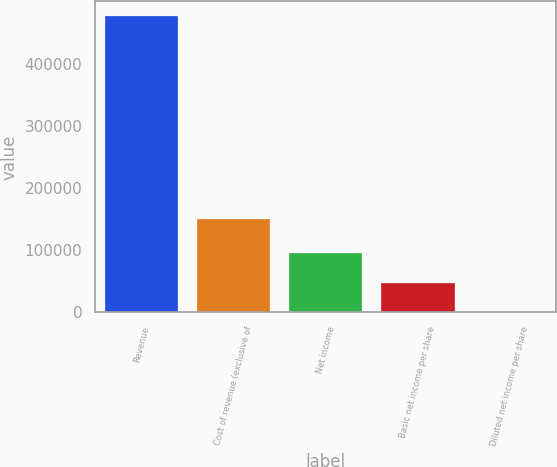Convert chart. <chart><loc_0><loc_0><loc_500><loc_500><bar_chart><fcel>Revenue<fcel>Cost of revenue (exclusive of<fcel>Net income<fcel>Basic net income per share<fcel>Diluted net income per share<nl><fcel>476035<fcel>149318<fcel>95207.3<fcel>47603.9<fcel>0.4<nl></chart> 